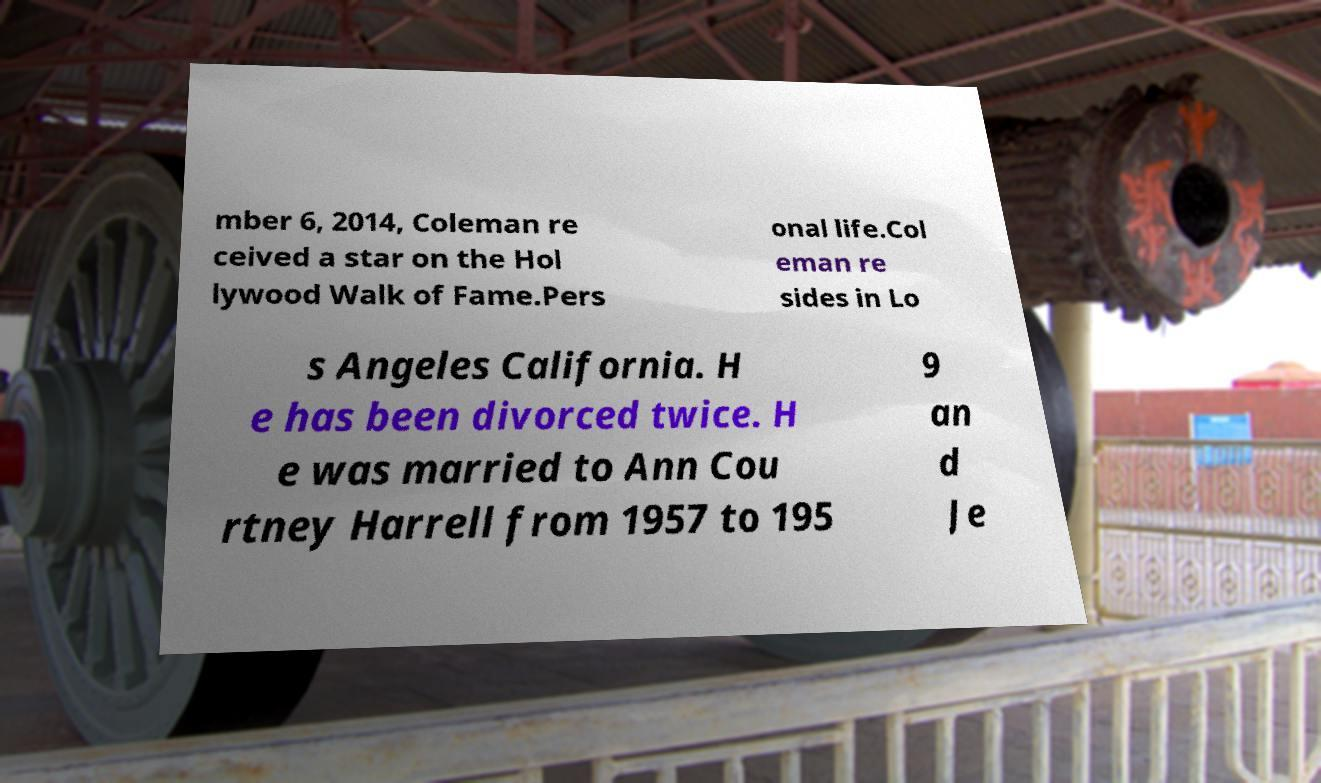Could you extract and type out the text from this image? mber 6, 2014, Coleman re ceived a star on the Hol lywood Walk of Fame.Pers onal life.Col eman re sides in Lo s Angeles California. H e has been divorced twice. H e was married to Ann Cou rtney Harrell from 1957 to 195 9 an d Je 